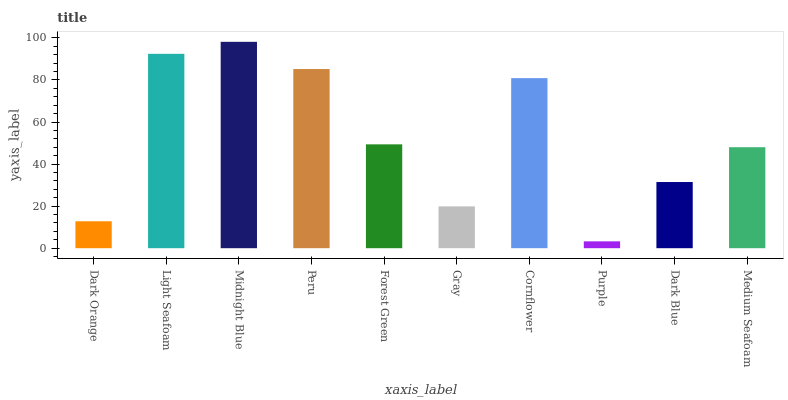Is Purple the minimum?
Answer yes or no. Yes. Is Midnight Blue the maximum?
Answer yes or no. Yes. Is Light Seafoam the minimum?
Answer yes or no. No. Is Light Seafoam the maximum?
Answer yes or no. No. Is Light Seafoam greater than Dark Orange?
Answer yes or no. Yes. Is Dark Orange less than Light Seafoam?
Answer yes or no. Yes. Is Dark Orange greater than Light Seafoam?
Answer yes or no. No. Is Light Seafoam less than Dark Orange?
Answer yes or no. No. Is Forest Green the high median?
Answer yes or no. Yes. Is Medium Seafoam the low median?
Answer yes or no. Yes. Is Dark Orange the high median?
Answer yes or no. No. Is Light Seafoam the low median?
Answer yes or no. No. 